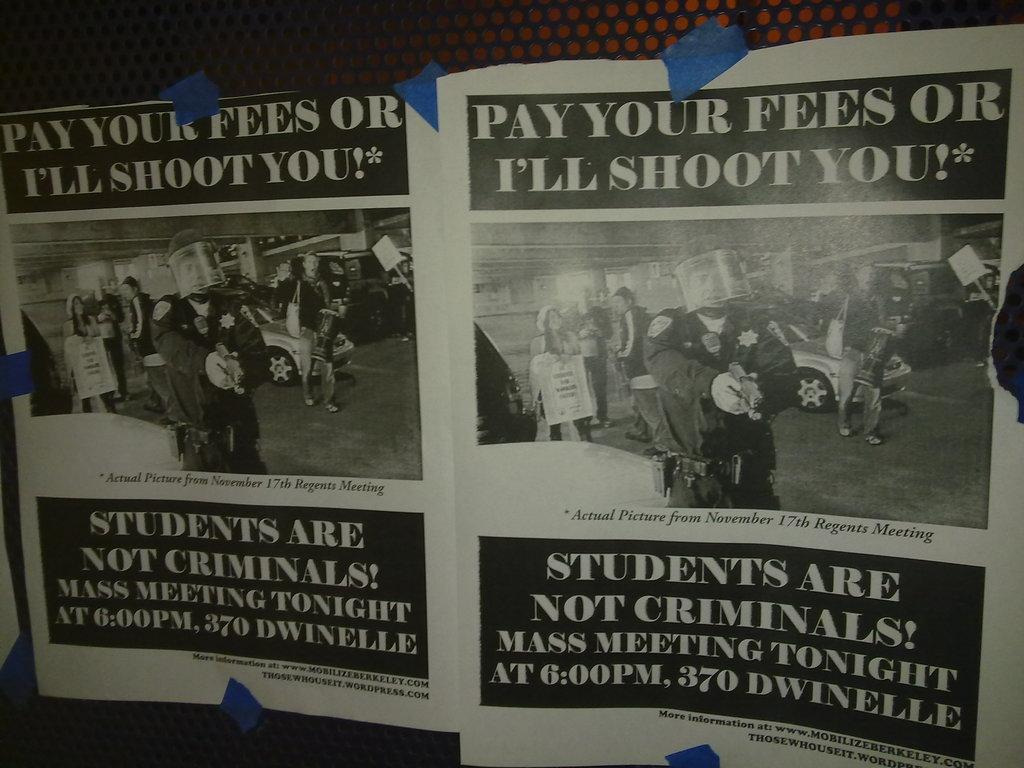Provide a one-sentence caption for the provided image. a picture of a leaflet from a newpaper article. 